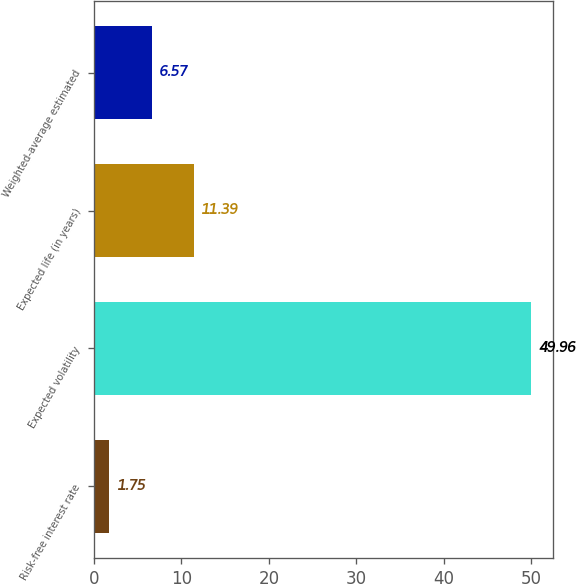<chart> <loc_0><loc_0><loc_500><loc_500><bar_chart><fcel>Risk-free interest rate<fcel>Expected volatility<fcel>Expected life (in years)<fcel>Weighted-average estimated<nl><fcel>1.75<fcel>49.96<fcel>11.39<fcel>6.57<nl></chart> 